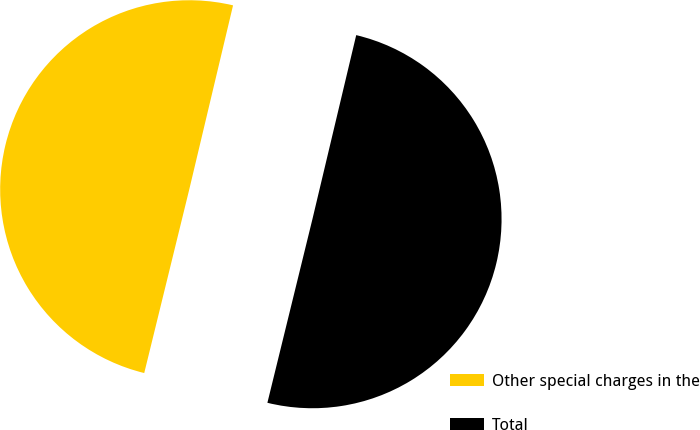Convert chart. <chart><loc_0><loc_0><loc_500><loc_500><pie_chart><fcel>Other special charges in the<fcel>Total<nl><fcel>49.89%<fcel>50.11%<nl></chart> 